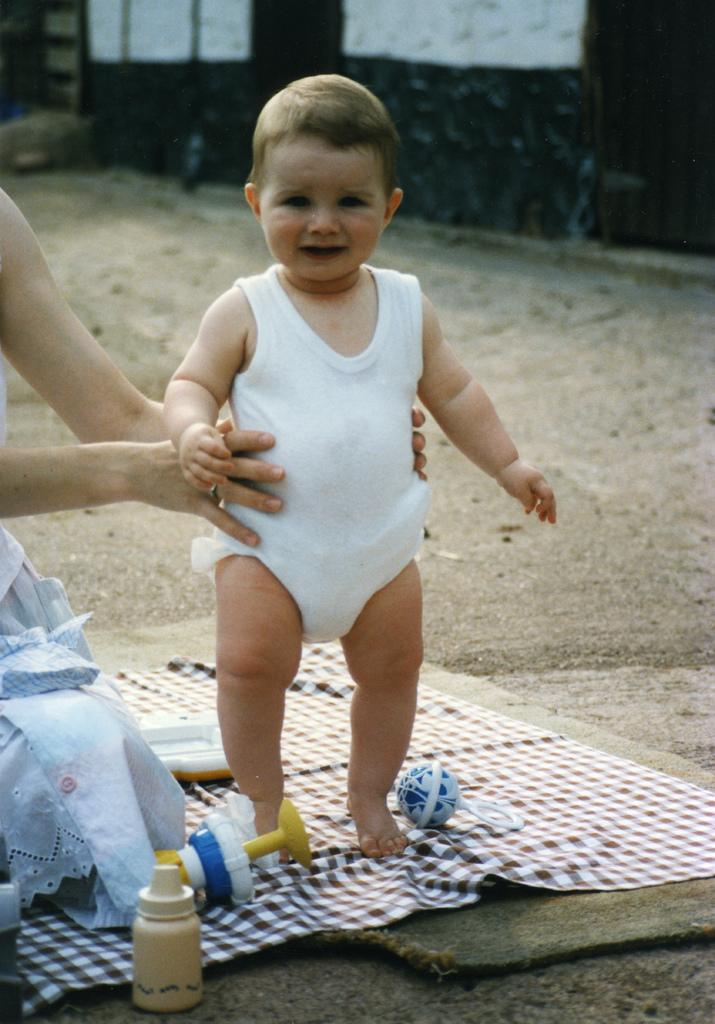Who is the main subject in the image? There is a woman in the image. What is the woman doing in the image? The woman is holding a baby. What can be seen in the foreground of the image? There is a bottle and toys placed on a surface in the foreground of the image. What is visible in the background of the image? There is a building visible in the background of the image. What type of amusement can be seen in the image? There is no amusement park or ride present in the image; it features a woman holding a baby with toys and a bottle in the foreground. What type of cup is the woman holding in the image? The woman is not holding a cup in the image; she is holding a baby. 